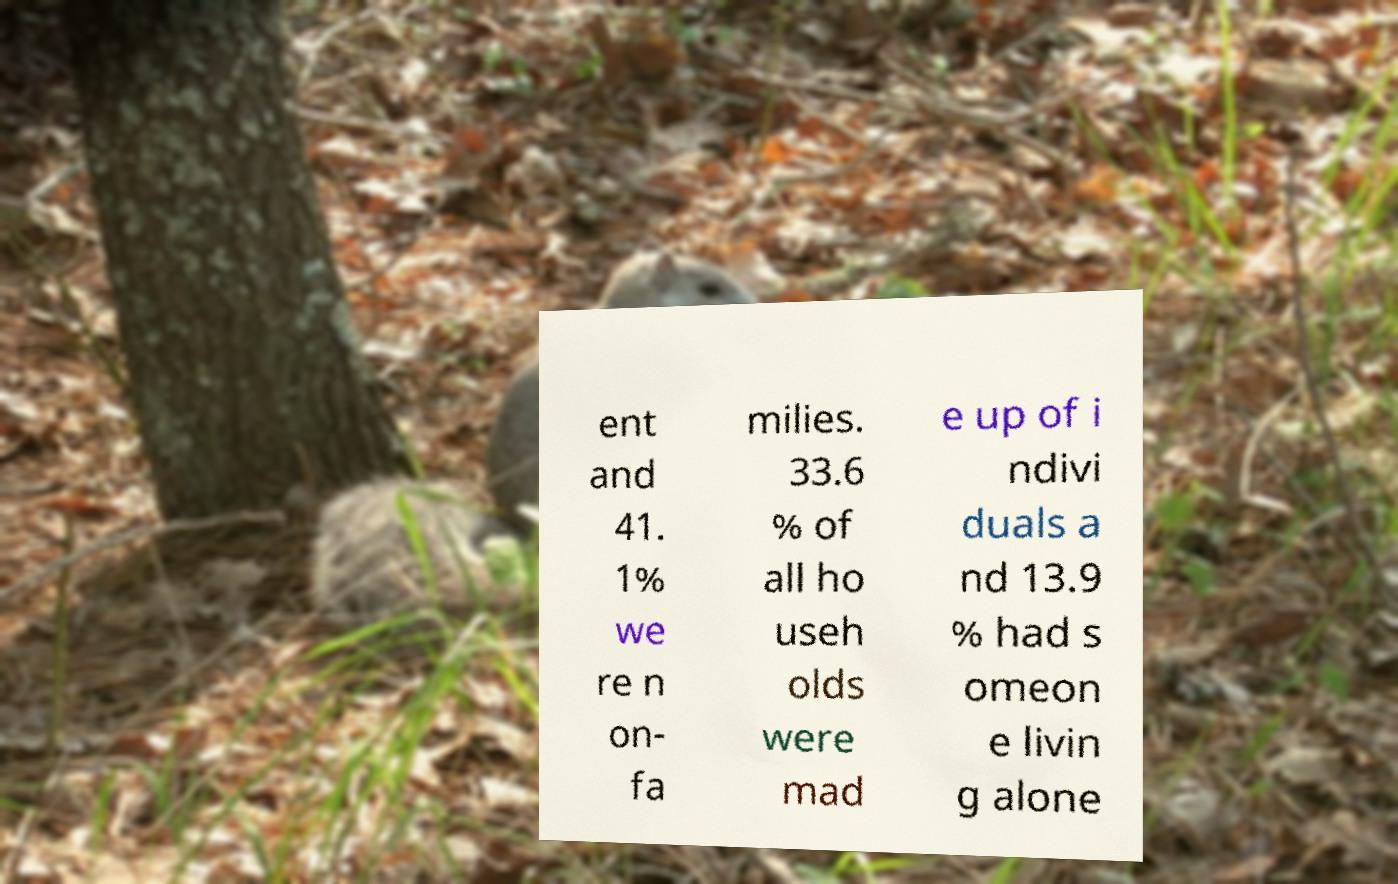Can you accurately transcribe the text from the provided image for me? ent and 41. 1% we re n on- fa milies. 33.6 % of all ho useh olds were mad e up of i ndivi duals a nd 13.9 % had s omeon e livin g alone 